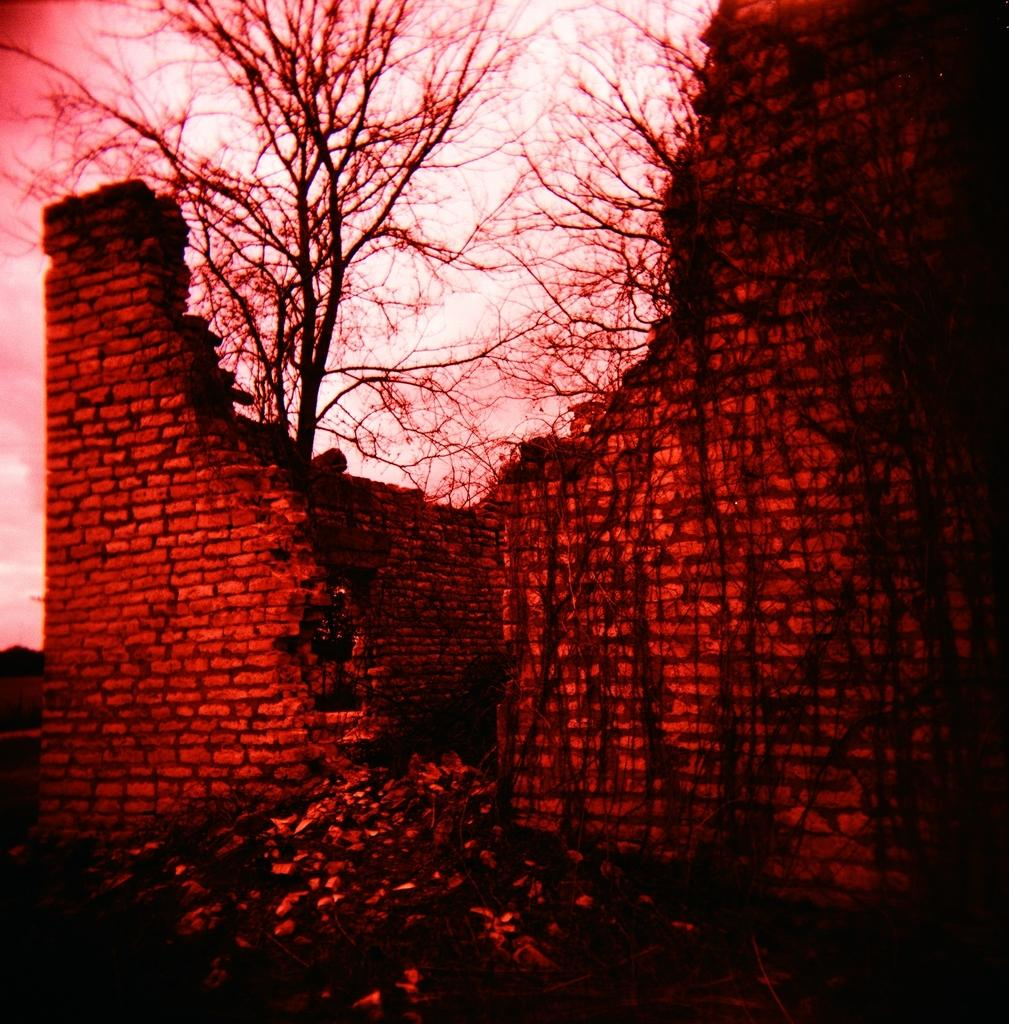What type of wall is depicted in the image? There is a red brick wall in the image. What can be seen in the background of the image? Dry trees and the sky are visible in the background of the image. What is the nature of the image? The image is a graphic representation. What is the price of the care in the image? There is no care or any item related to a vehicle present in the image. 